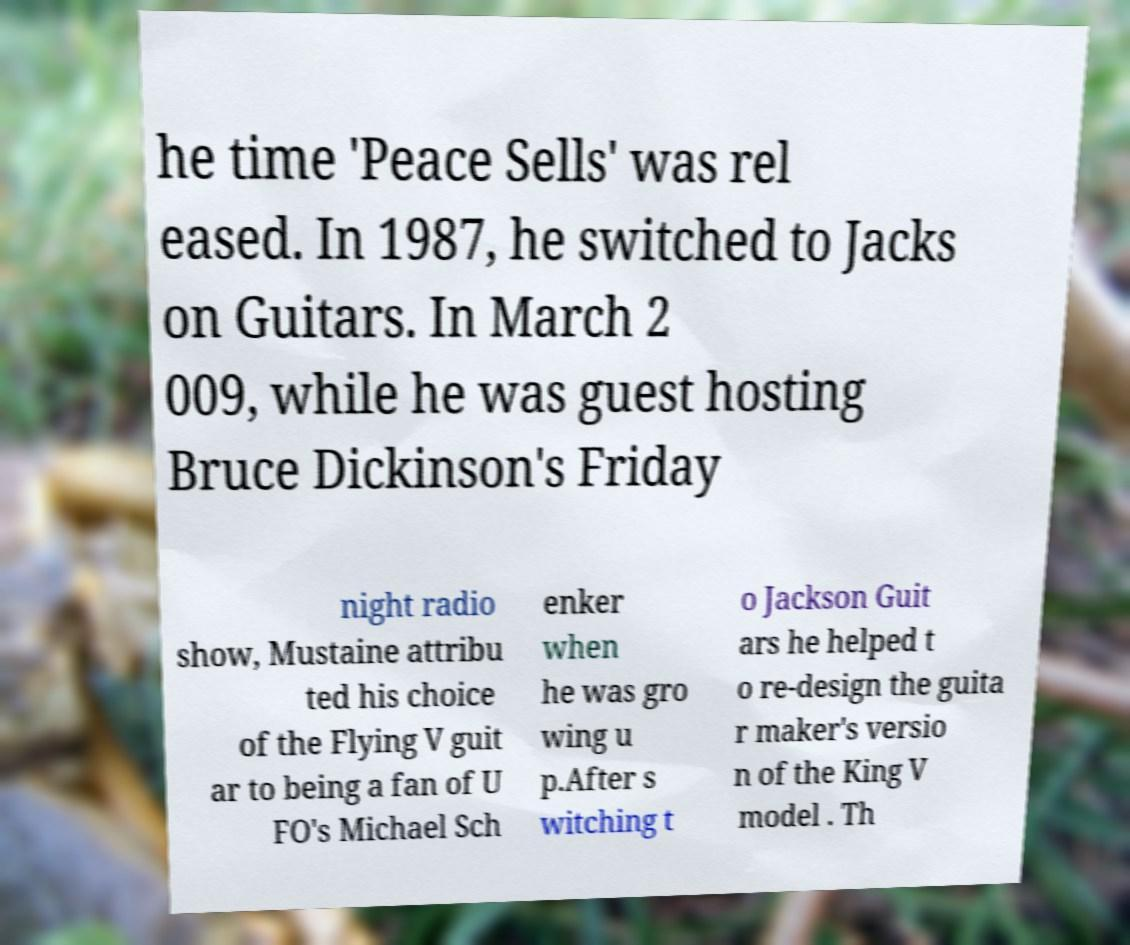What messages or text are displayed in this image? I need them in a readable, typed format. he time 'Peace Sells' was rel eased. In 1987, he switched to Jacks on Guitars. In March 2 009, while he was guest hosting Bruce Dickinson's Friday night radio show, Mustaine attribu ted his choice of the Flying V guit ar to being a fan of U FO's Michael Sch enker when he was gro wing u p.After s witching t o Jackson Guit ars he helped t o re-design the guita r maker's versio n of the King V model . Th 